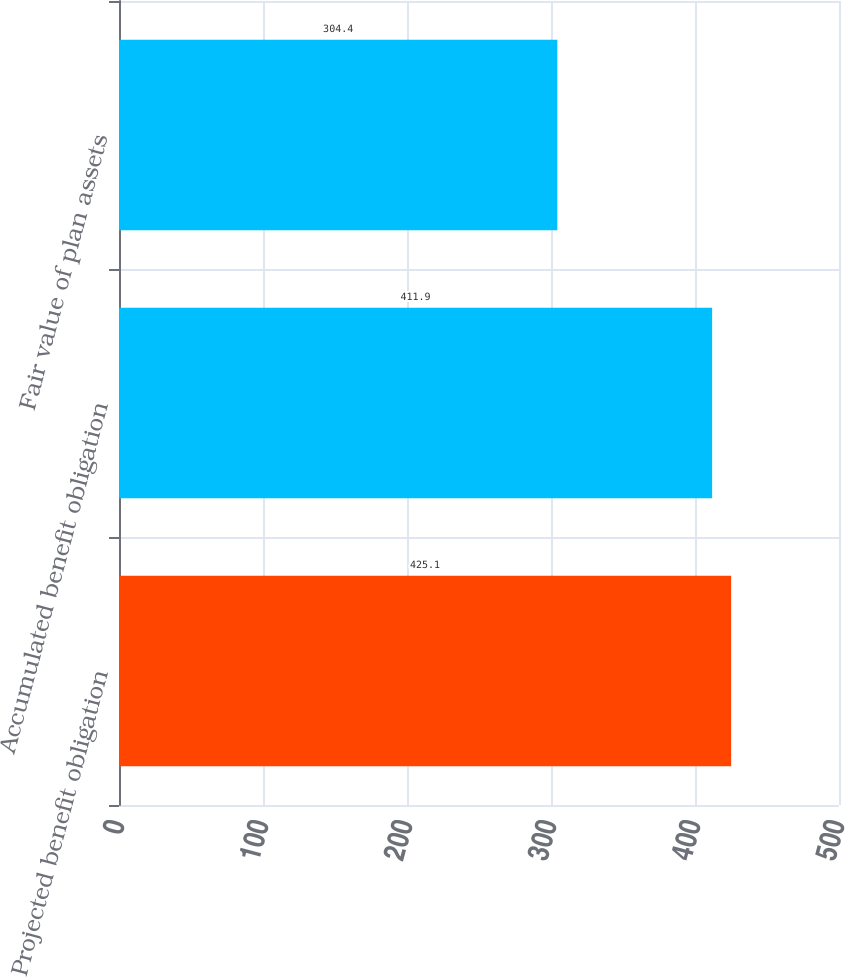Convert chart to OTSL. <chart><loc_0><loc_0><loc_500><loc_500><bar_chart><fcel>Projected benefit obligation<fcel>Accumulated benefit obligation<fcel>Fair value of plan assets<nl><fcel>425.1<fcel>411.9<fcel>304.4<nl></chart> 